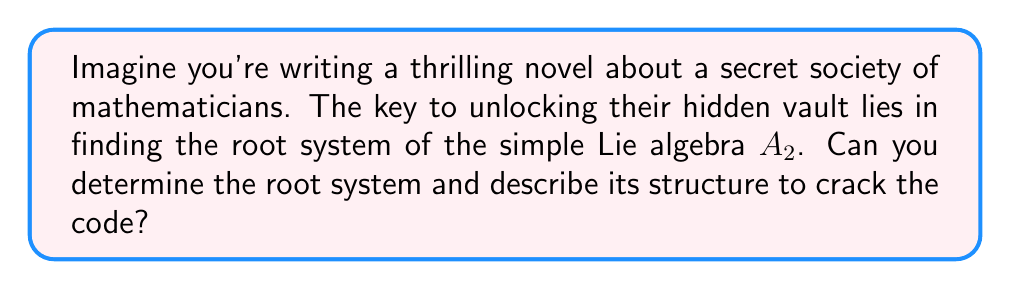Give your solution to this math problem. To find the root system of the simple Lie algebra $A_2$, we need to follow these steps:

1) First, recall that $A_2$ corresponds to the special linear group $SL(3, \mathbb{C})$, which consists of 3x3 complex matrices with determinant 1.

2) The rank of $A_2$ is 2, so we work in a 2-dimensional real vector space with an inner product.

3) The positive roots of $A_2$ are:
   $\alpha_1 = (1, 0)$
   $\alpha_2 = (-\frac{1}{2}, \frac{\sqrt{3}}{2})$
   $\alpha_1 + \alpha_2 = (\frac{1}{2}, \frac{\sqrt{3}}{2})$

4) The negative roots are the negatives of these:
   $-\alpha_1 = (-1, 0)$
   $-\alpha_2 = (\frac{1}{2}, -\frac{\sqrt{3}}{2})$
   $-(\alpha_1 + \alpha_2) = (-\frac{1}{2}, -\frac{\sqrt{3}}{2})$

5) The root system consists of all these roots:
   $\{\pm\alpha_1, \pm\alpha_2, \pm(\alpha_1 + \alpha_2)\}$

6) Geometrically, these roots form a hexagon in the plane. The angles between adjacent roots are 60°.

[asy]
unitsize(1cm);
draw((-1,0)--(1,0),arrow=Arrow(TeXHead));
draw((0,-1.732)--(0,1.732),arrow=Arrow(TeXHead));
draw((-1,0)--(-0.5,0.866)--(0.5,0.866)--(1,0)--(0.5,-0.866)--(-0.5,-0.866)--cycle,blue);
dot((-1,0)); dot((1,0)); dot((-0.5,0.866)); dot((0.5,0.866)); dot((0.5,-0.866)); dot((-0.5,-0.866));
label("$\alpha_1$",(1,0),E);
label("$\alpha_2$",(-0.5,0.866),NW);
label("$\alpha_1+\alpha_2$",(0.5,0.866),NE);
[/asy]

7) This root system has several important properties:
   - It's symmetric about the origin
   - The only scalar multiples of roots that are also roots are 1 and -1
   - The sum of two roots is a root if and only if they form a 120° angle

Understanding this structure is crucial for unlocking the secrets of the $A_2$ Lie algebra and, in our thrilling scenario, cracking the code to the mathematicians' vault.
Answer: The root system of the simple Lie algebra $A_2$ consists of six vectors in a 2-dimensional space:
$$\{\pm(1,0), \pm(-\frac{1}{2},\frac{\sqrt{3}}{2}), \pm(\frac{1}{2},\frac{\sqrt{3}}{2})\}$$
These form a regular hexagon in the plane, with adjacent roots at 60° angles to each other. 